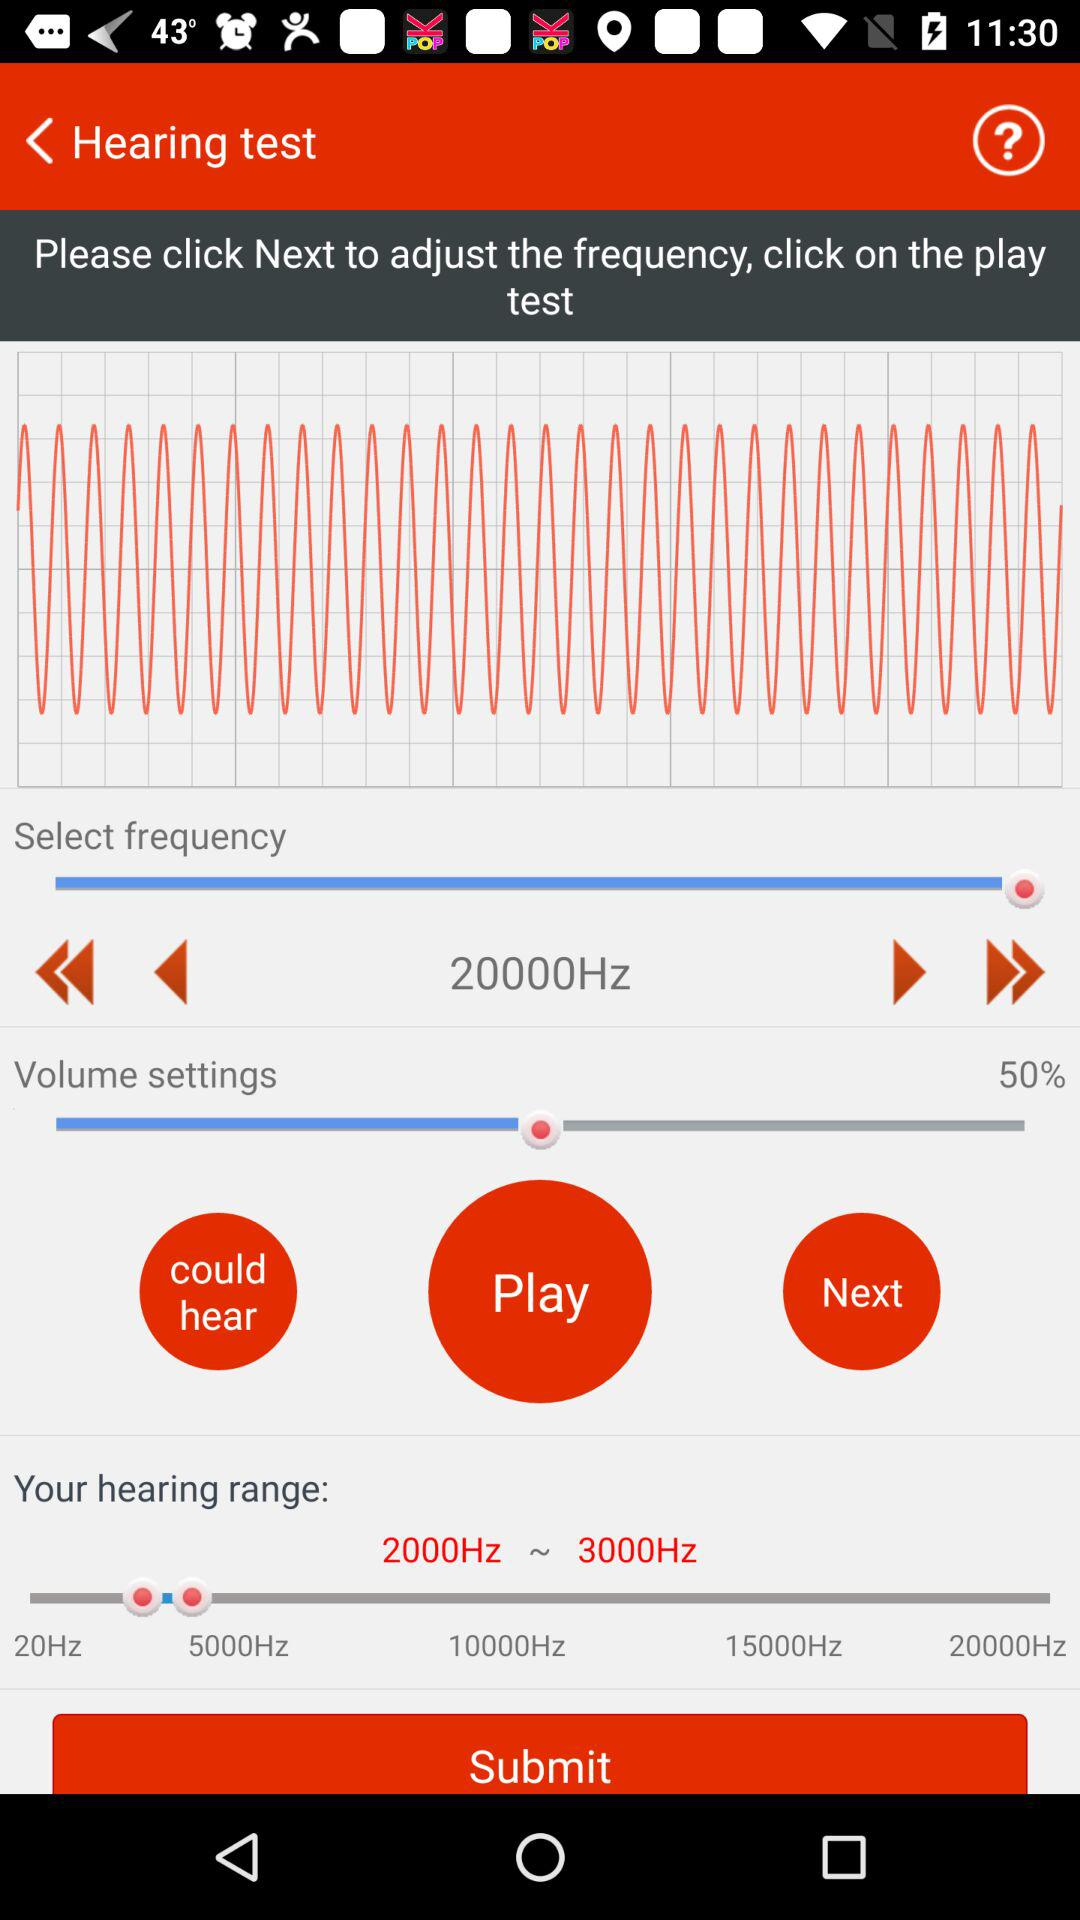What is the set frequency range? The set frequency range is 20000Hz. 